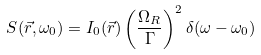Convert formula to latex. <formula><loc_0><loc_0><loc_500><loc_500>S ( { \vec { r } } , \omega _ { 0 } ) = I _ { 0 } ( { \vec { r } } ) \left ( { \frac { \Omega _ { R } } { \Gamma } } \right ) ^ { 2 } \delta ( \omega - \omega _ { 0 } )</formula> 